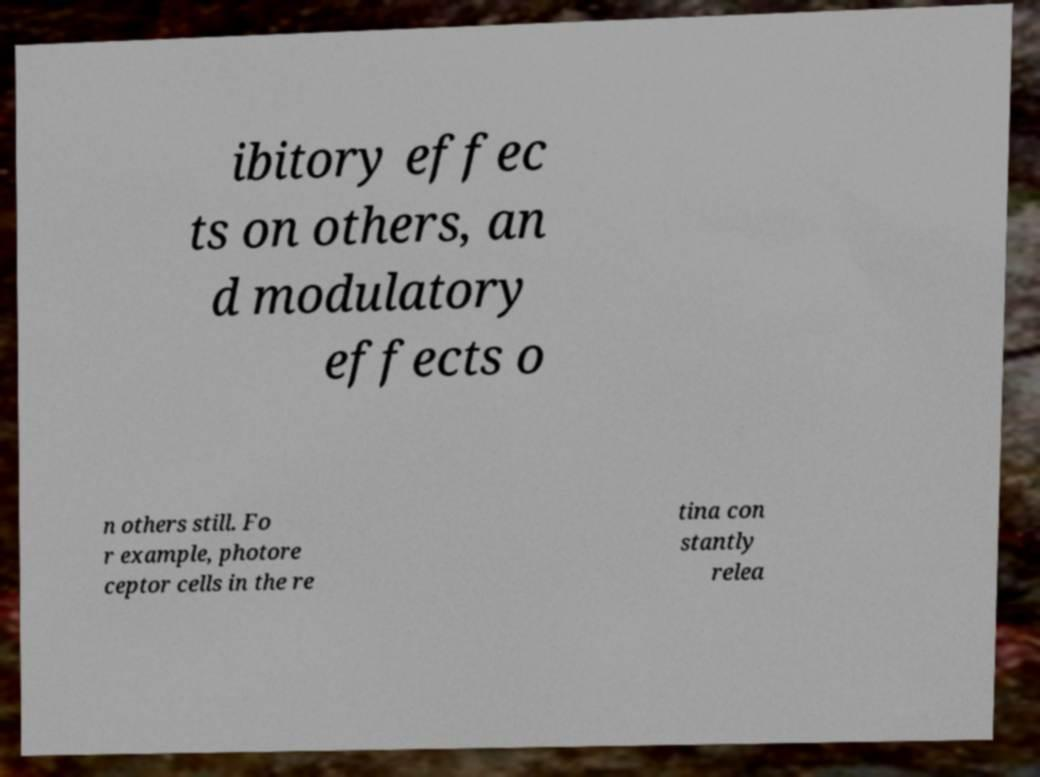Can you read and provide the text displayed in the image?This photo seems to have some interesting text. Can you extract and type it out for me? ibitory effec ts on others, an d modulatory effects o n others still. Fo r example, photore ceptor cells in the re tina con stantly relea 